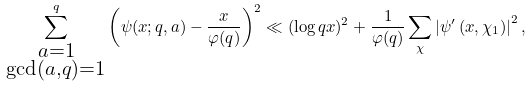Convert formula to latex. <formula><loc_0><loc_0><loc_500><loc_500>\sum _ { \substack { a = 1 \\ \gcd ( a , q ) = 1 } } ^ { q } \left ( \psi ( x ; q , a ) - \frac { x } { \varphi ( q ) } \right ) ^ { 2 } \ll ( \log q x ) ^ { 2 } + \frac { 1 } { \varphi ( q ) } \sum _ { \chi } \left | \psi ^ { \prime } \left ( x , \chi _ { 1 } \right ) \right | ^ { 2 } ,</formula> 